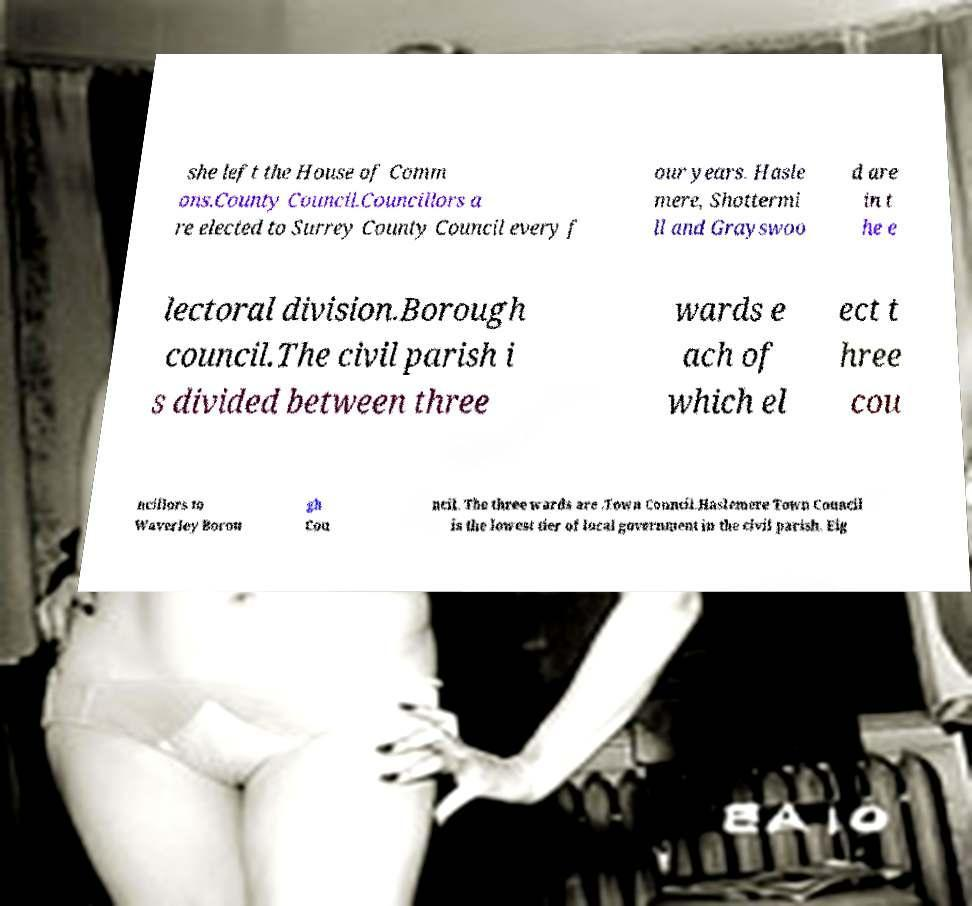For documentation purposes, I need the text within this image transcribed. Could you provide that? she left the House of Comm ons.County Council.Councillors a re elected to Surrey County Council every f our years. Hasle mere, Shottermi ll and Grayswoo d are in t he e lectoral division.Borough council.The civil parish i s divided between three wards e ach of which el ect t hree cou ncillors to Waverley Borou gh Cou ncil. The three wards are .Town Council.Haslemere Town Council is the lowest tier of local government in the civil parish. Eig 